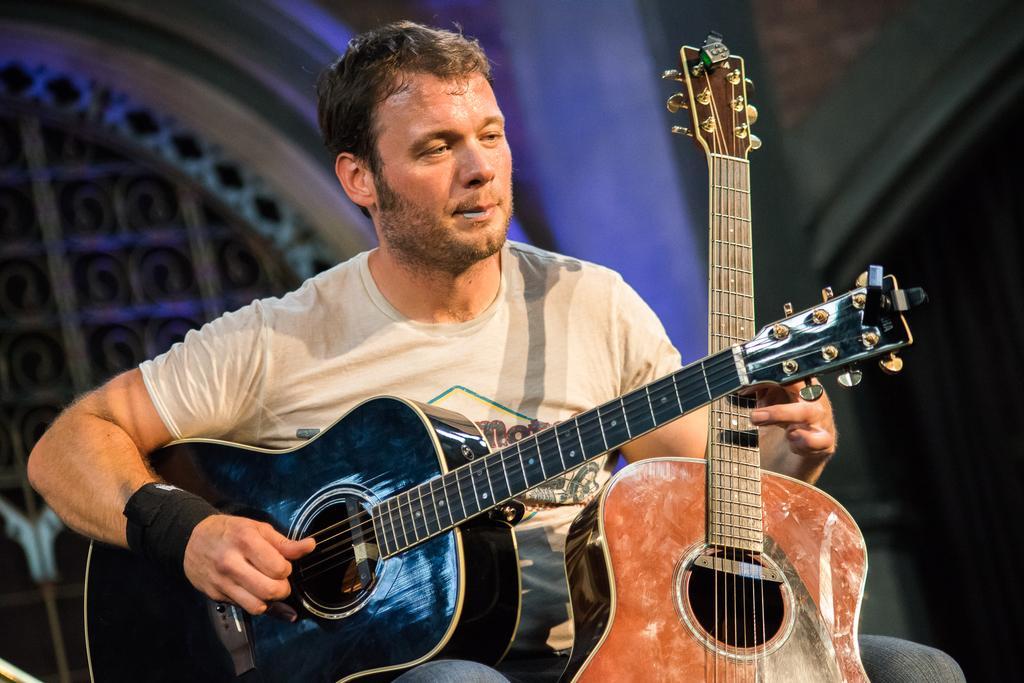Describe this image in one or two sentences. In this image there is a person playing two guitars, behind him there is a building. 